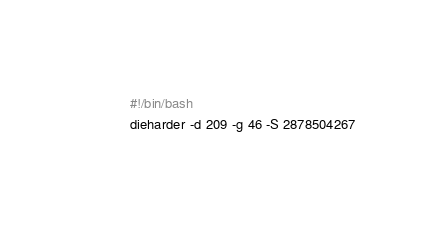<code> <loc_0><loc_0><loc_500><loc_500><_Bash_>#!/bin/bash
dieharder -d 209 -g 46 -S 2878504267
</code> 